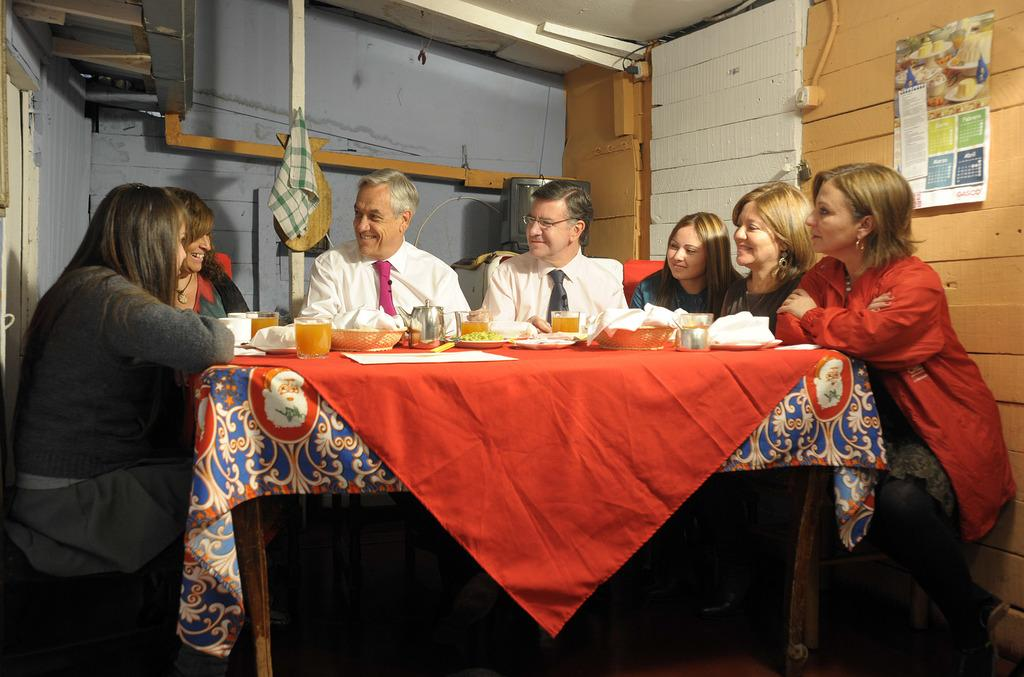How many people are in the image? There is a group of people in the image, but the exact number is not specified. What are the people doing in the image? The people are sitting around a table in the image. What items can be seen on the table? There are glasses, baskets, and plates on the table in the image. What can be seen in the background of the image? There is a wall and a calendar in the background of the image. What type of neck can be seen on the donkey in the image? There is no donkey present in the image, so it is not possible to answer that question. 